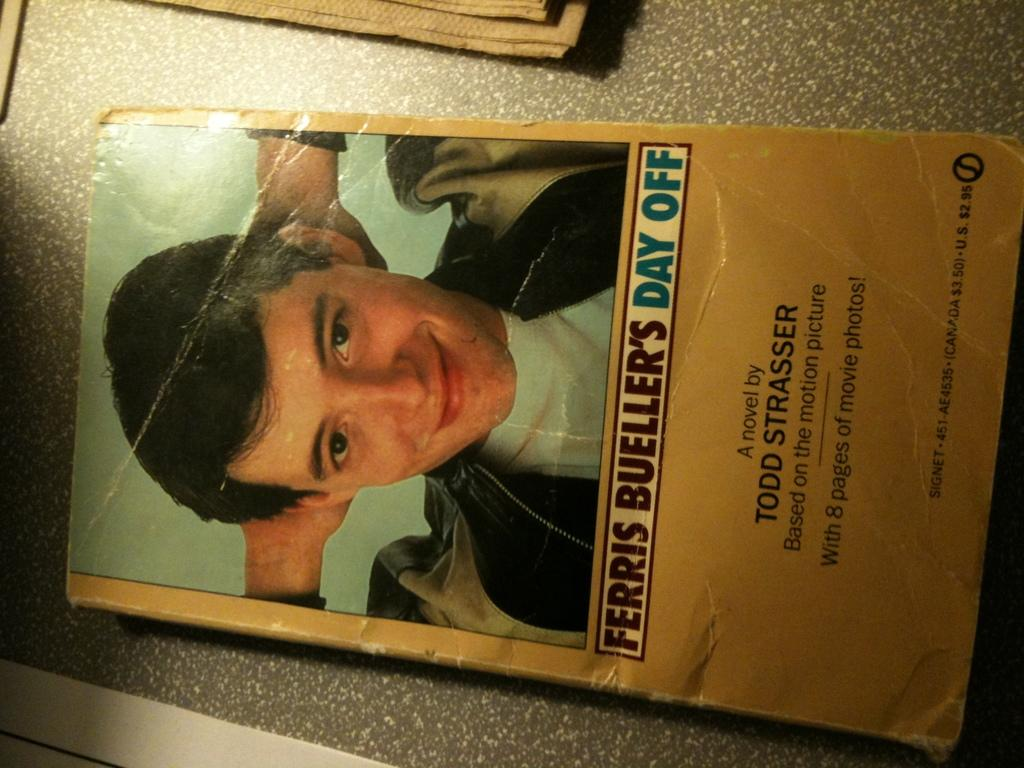What object can be seen in the image? There is a book in the image. Where is the book located? The book is placed on a table. How many ladybugs are crawling on the book in the image? There are no ladybugs present in the image; it only features a book placed on a table. 